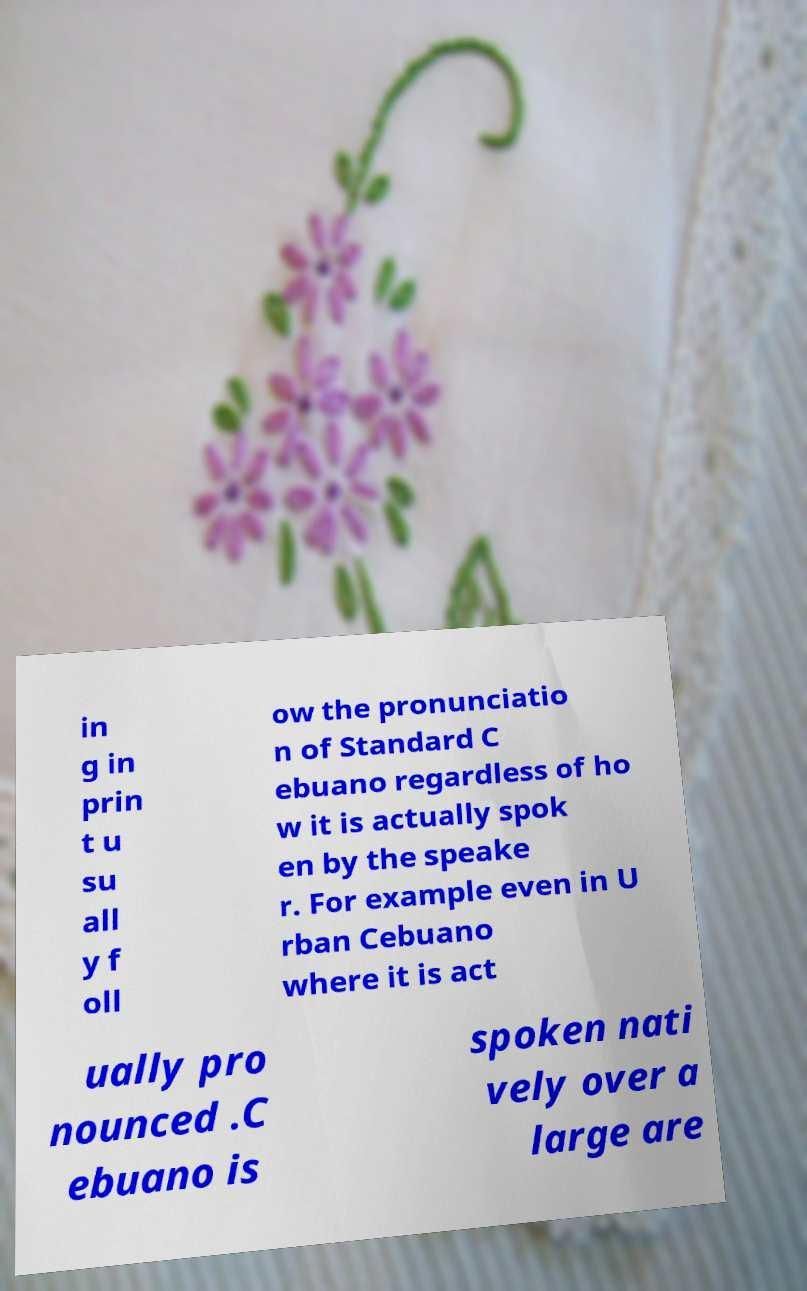Please identify and transcribe the text found in this image. in g in prin t u su all y f oll ow the pronunciatio n of Standard C ebuano regardless of ho w it is actually spok en by the speake r. For example even in U rban Cebuano where it is act ually pro nounced .C ebuano is spoken nati vely over a large are 